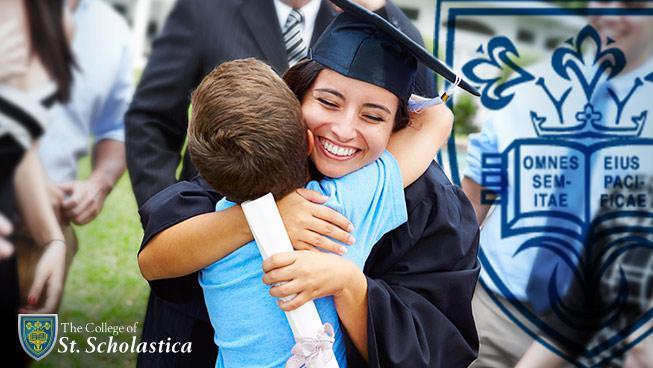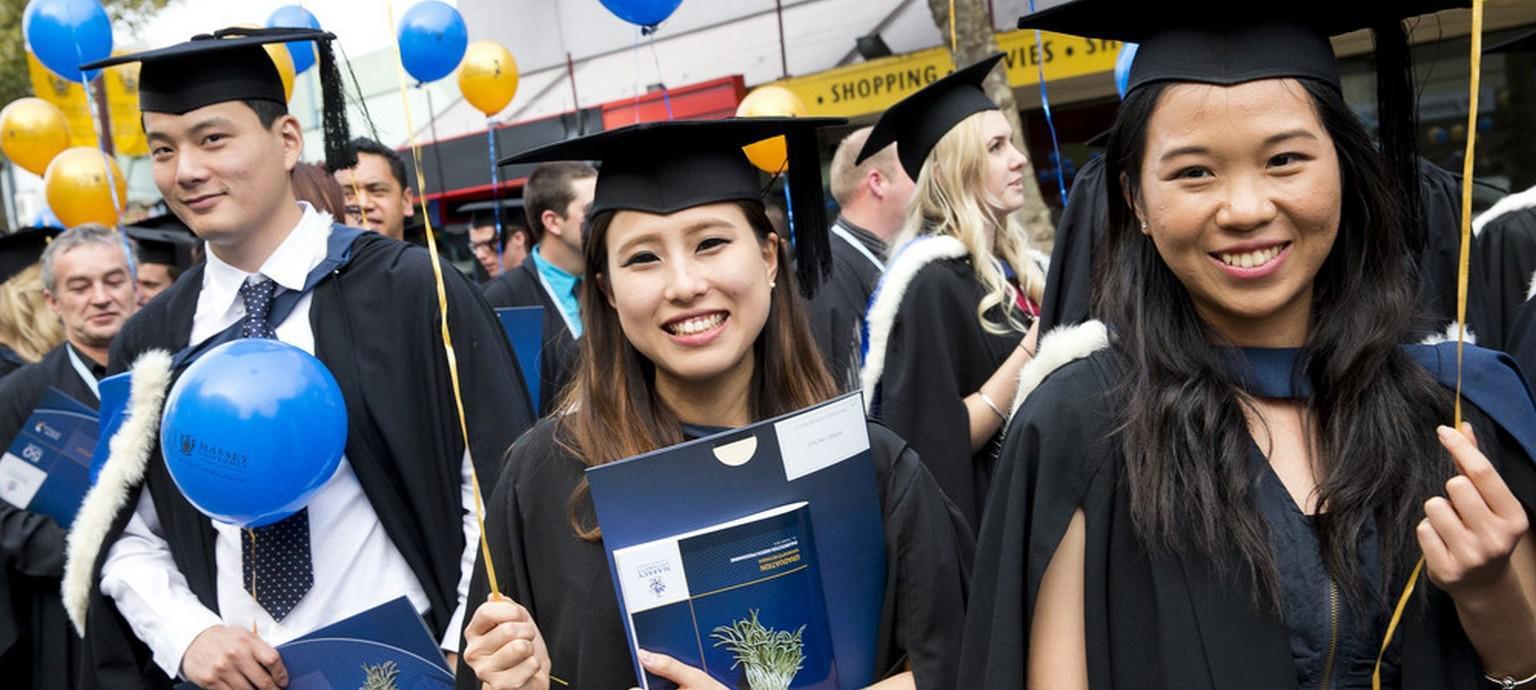The first image is the image on the left, the second image is the image on the right. Examine the images to the left and right. Is the description "The right image features graduates in black robes and caps, with blue and yellow balloons in the air." accurate? Answer yes or no. Yes. The first image is the image on the left, the second image is the image on the right. For the images displayed, is the sentence "Several people stand in a single line outside in the grass in the image on the right." factually correct? Answer yes or no. No. 